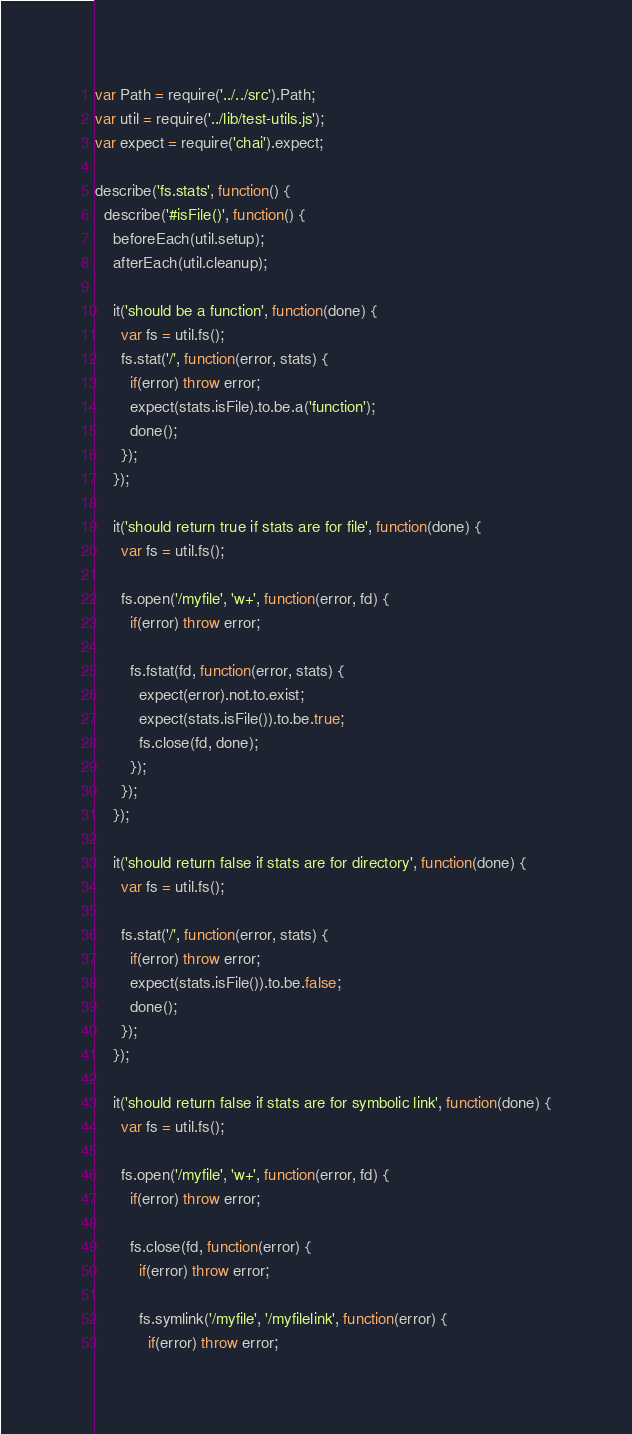Convert code to text. <code><loc_0><loc_0><loc_500><loc_500><_JavaScript_>var Path = require('../../src').Path;
var util = require('../lib/test-utils.js');
var expect = require('chai').expect;

describe('fs.stats', function() {
  describe('#isFile()', function() {
    beforeEach(util.setup);
    afterEach(util.cleanup);

    it('should be a function', function(done) {
      var fs = util.fs();
      fs.stat('/', function(error, stats) {
        if(error) throw error;
        expect(stats.isFile).to.be.a('function');
        done();
      });
    });

    it('should return true if stats are for file', function(done) {
      var fs = util.fs();

      fs.open('/myfile', 'w+', function(error, fd) {
        if(error) throw error;

        fs.fstat(fd, function(error, stats) {
          expect(error).not.to.exist;
          expect(stats.isFile()).to.be.true;
          fs.close(fd, done);
        });
      });
    });

    it('should return false if stats are for directory', function(done) {
      var fs = util.fs();

      fs.stat('/', function(error, stats) {
        if(error) throw error;
        expect(stats.isFile()).to.be.false;
        done();
      });
    });

    it('should return false if stats are for symbolic link', function(done) {
      var fs = util.fs();

      fs.open('/myfile', 'w+', function(error, fd) {
        if(error) throw error;

        fs.close(fd, function(error) {
          if(error) throw error;

          fs.symlink('/myfile', '/myfilelink', function(error) {
            if(error) throw error;</code> 